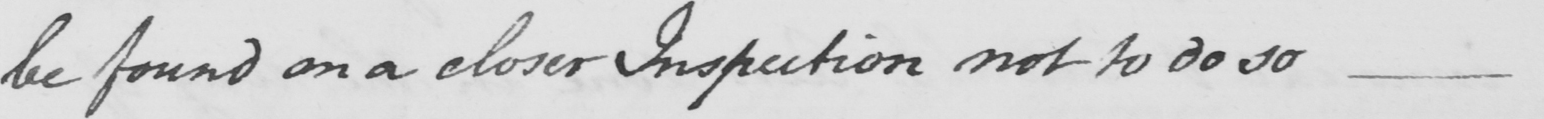What is written in this line of handwriting? be found on a closer Inspection not to do so  _ 